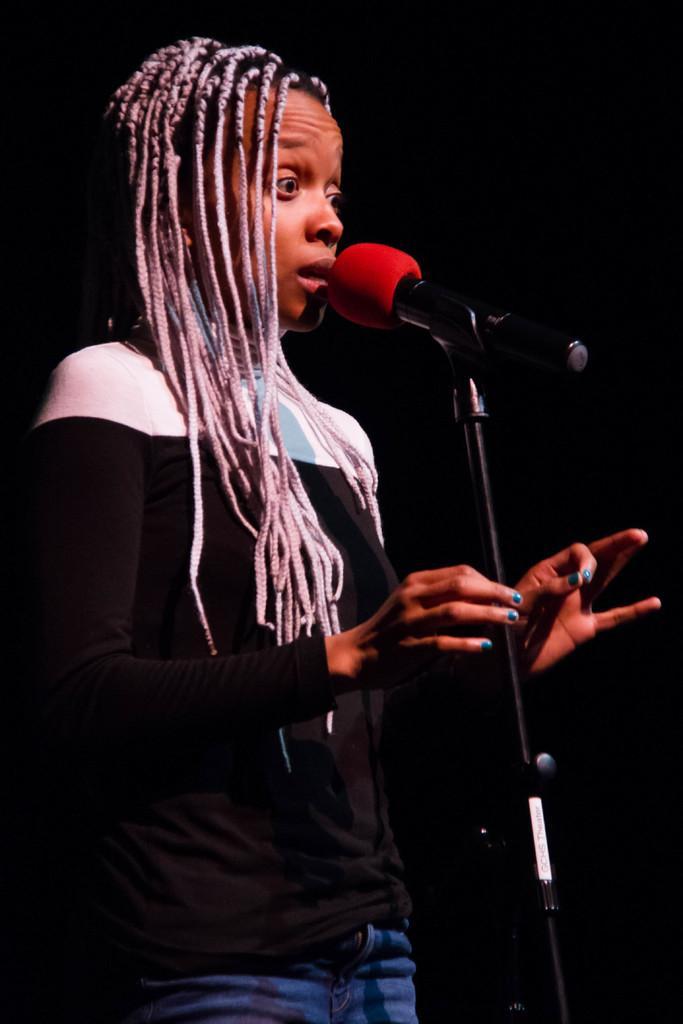Please provide a concise description of this image. On the left side of this image I can see a woman wearing black color t-shirt, standing facing towards the right side. In front of her there is a mike stand. It seems like she's singing. The background is in black color. 